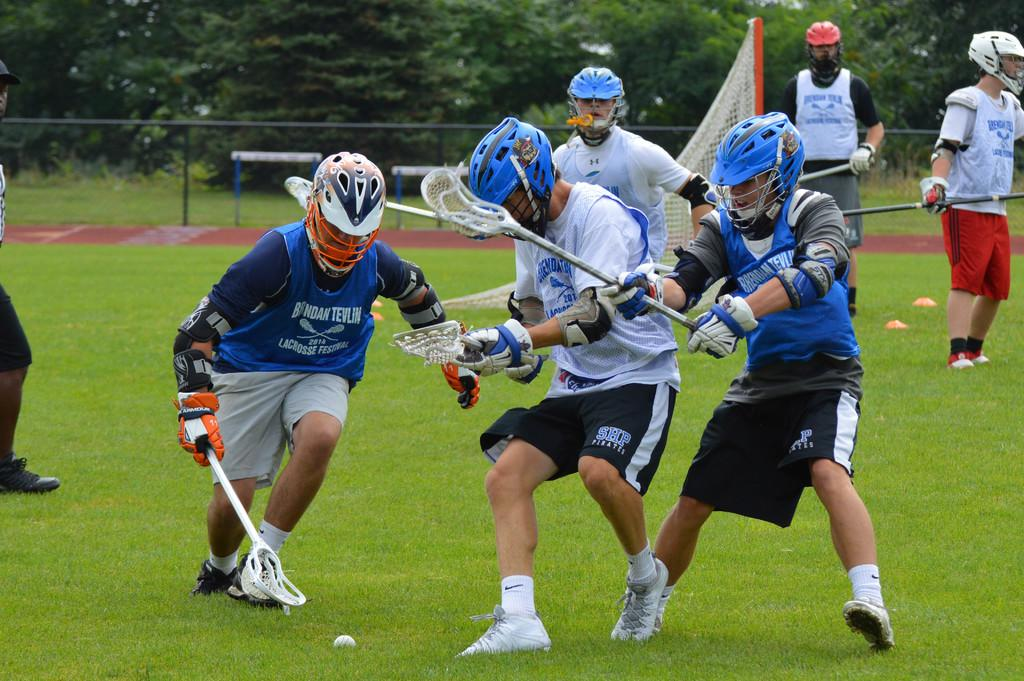How many people are in the image? There are many people in the image. What are the people wearing on their heads? The people are wearing helmets. What activity are the people engaged in? The people are playing a game. Where is the game being played? The game is being played on a grass field. How many hours of sleep are the people getting during the game in the image? The image does not provide information about the people's sleep, so it cannot be determined. 